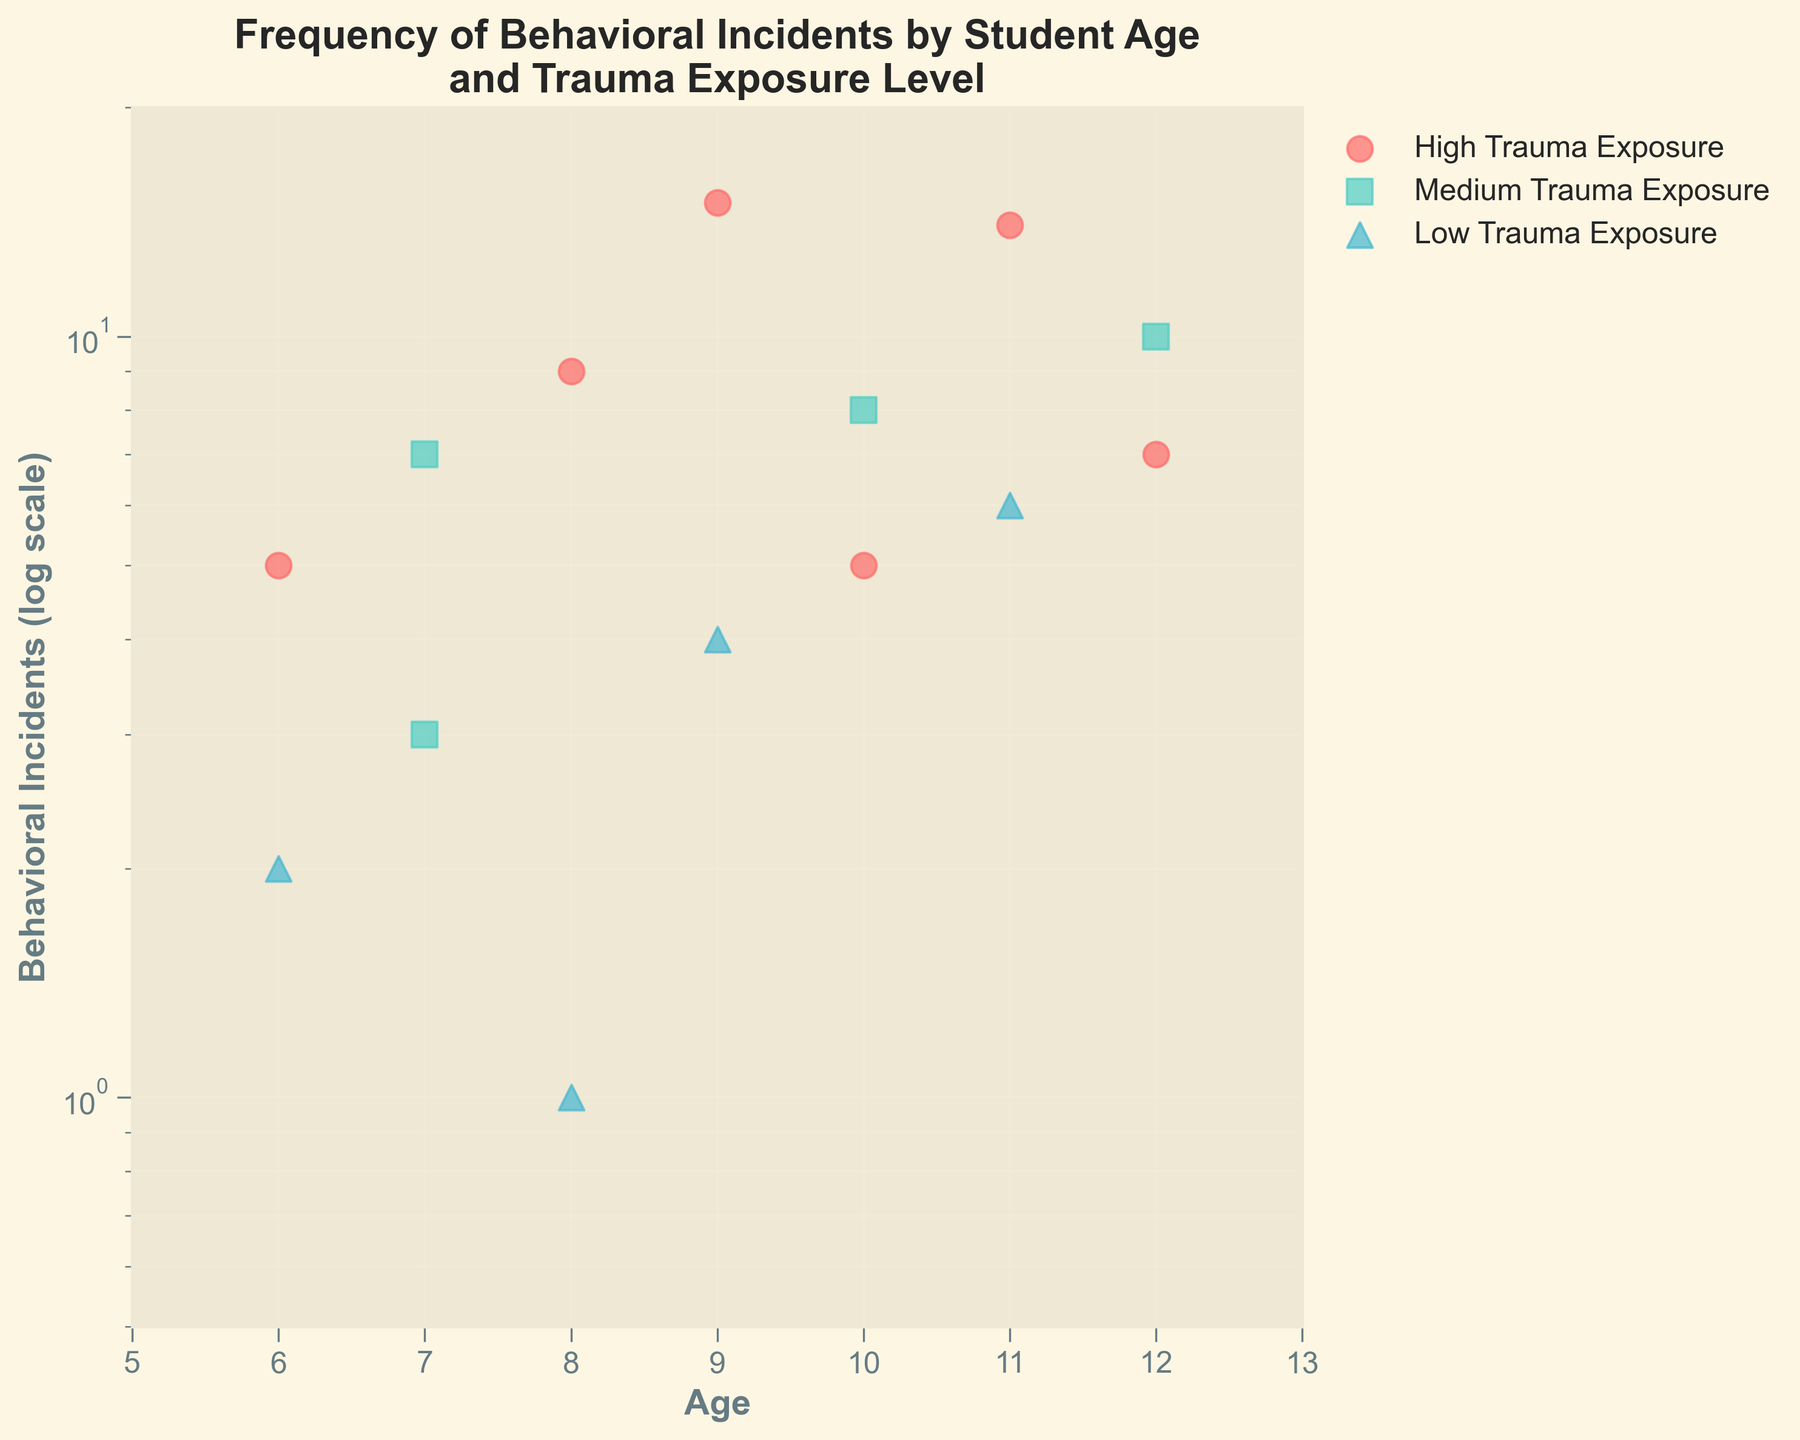What's the title of the figure? The title of the figure is displayed at the top in large, bold text. It reads "Frequency of Behavioral Incidents by Student Age and Trauma Exposure Level".
Answer: Frequency of Behavioral Incidents by Student Age and Trauma Exposure Level What does the y-axis represent? The y-axis is labeled "Behavioral Incidents (log scale)", indicating it measures the number of behavioral incidents on a logarithmic scale.
Answer: Behavioral Incidents (log scale) Which trauma exposure level has the highest number of behavioral incidents? By looking at the color and marker of the data points, the red circles (High Trauma Exposure) have the highest number of behavioral incidents, notably around 9 and 11 years of age.
Answer: High How many data points are there for students aged 10? At age 10, there are two data points marked by a green square (Medium) at 8 incidents and a red circle (High) at 5 incidents.
Answer: 2 What's the behavioral incident count for the student aged 7 with medium trauma exposure? For students aged 7, there are two data points with medium trauma exposure indicated by green squares. They have incident counts of 7 and 3.
Answer: 3 and 7 What's the age of the student with the lowest number of behavioral incidents? The data point with the lowest number of behavioral incidents is at age 8 with 1 incident, indicated by a blue triangle (Low Trauma Exposure).
Answer: 8 What is the range of ages included in this dataset? The x-axis shows that ages range from 6 to 12 years old based on the spread of data points.
Answer: 6 to 12 Which trauma exposure level shows the highest variance in behavioral incidents? Looking at the scatter plot, High Trauma Exposure (red circles) has points spread widely across the y-axis, indicating high variance in behavioral incidents.
Answer: High Does medium trauma exposure show more incidents at age 10 or age 12? By inspecting the green squares, age 10 has an incident count of 8, and age 12 has an incident count of 10 for medium trauma exposure.
Answer: Age 12 Which age group has the most data points for high trauma exposure? By counting the red circles, age 11 has the most high trauma exposure data points with behavioral incidents of 14.
Answer: Age 11 